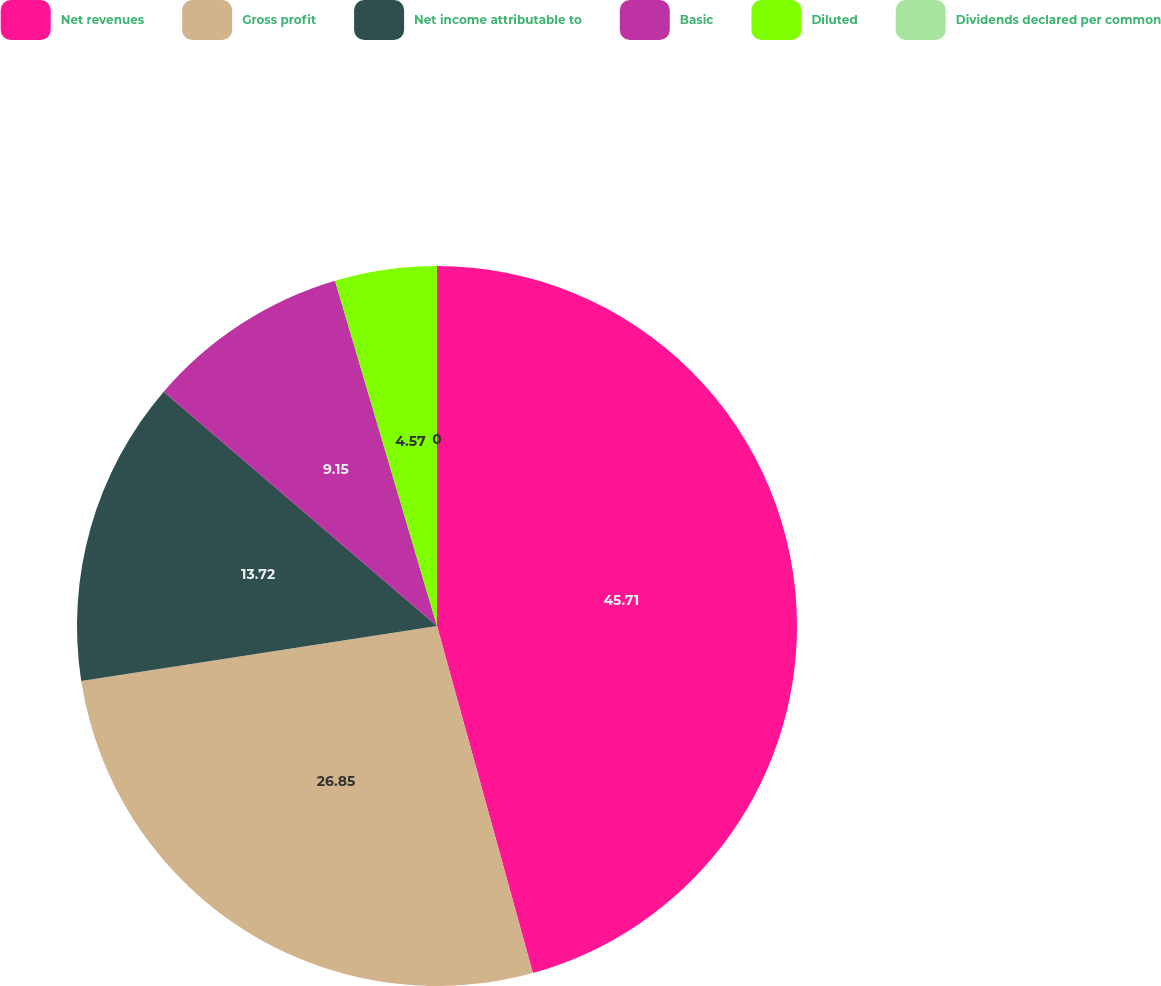Convert chart to OTSL. <chart><loc_0><loc_0><loc_500><loc_500><pie_chart><fcel>Net revenues<fcel>Gross profit<fcel>Net income attributable to<fcel>Basic<fcel>Diluted<fcel>Dividends declared per common<nl><fcel>45.71%<fcel>26.85%<fcel>13.72%<fcel>9.15%<fcel>4.57%<fcel>0.0%<nl></chart> 